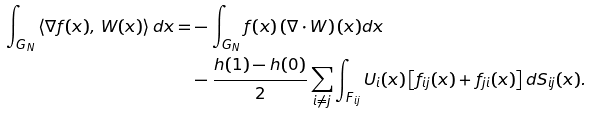<formula> <loc_0><loc_0><loc_500><loc_500>\int _ { G _ { N } } \left \langle \nabla f ( x ) , \, W ( x ) \right \rangle d x = & - \int _ { G _ { N } } f ( x ) \left ( \nabla \cdot W \right ) ( x ) d x \\ & - \frac { h ( 1 ) - h ( 0 ) } { 2 } \sum _ { i \neq j } \int _ { F _ { i j } } U _ { i } ( x ) \left [ f _ { i j } ( x ) + f _ { j i } ( x ) \right ] d S _ { i j } ( x ) .</formula> 